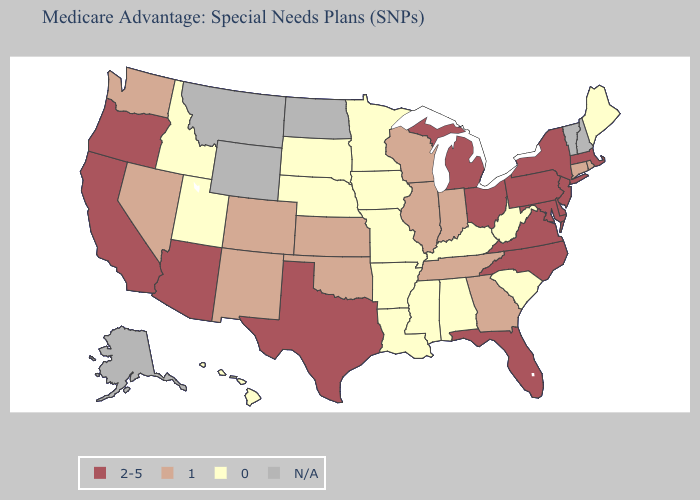Does Rhode Island have the lowest value in the USA?
Quick response, please. No. What is the lowest value in the Northeast?
Be succinct. 0. What is the value of Nebraska?
Keep it brief. 0. Name the states that have a value in the range 1?
Write a very short answer. Colorado, Connecticut, Georgia, Illinois, Indiana, Kansas, New Mexico, Nevada, Oklahoma, Rhode Island, Tennessee, Washington, Wisconsin. What is the lowest value in the USA?
Concise answer only. 0. Does West Virginia have the highest value in the USA?
Concise answer only. No. Name the states that have a value in the range 1?
Be succinct. Colorado, Connecticut, Georgia, Illinois, Indiana, Kansas, New Mexico, Nevada, Oklahoma, Rhode Island, Tennessee, Washington, Wisconsin. Which states hav the highest value in the West?
Be succinct. Arizona, California, Oregon. What is the lowest value in the Northeast?
Quick response, please. 0. Does Louisiana have the lowest value in the USA?
Concise answer only. Yes. Name the states that have a value in the range 2-5?
Quick response, please. Arizona, California, Delaware, Florida, Massachusetts, Maryland, Michigan, North Carolina, New Jersey, New York, Ohio, Oregon, Pennsylvania, Texas, Virginia. Among the states that border Pennsylvania , which have the highest value?
Answer briefly. Delaware, Maryland, New Jersey, New York, Ohio. Does Minnesota have the highest value in the USA?
Answer briefly. No. Is the legend a continuous bar?
Give a very brief answer. No. What is the value of Ohio?
Answer briefly. 2-5. 